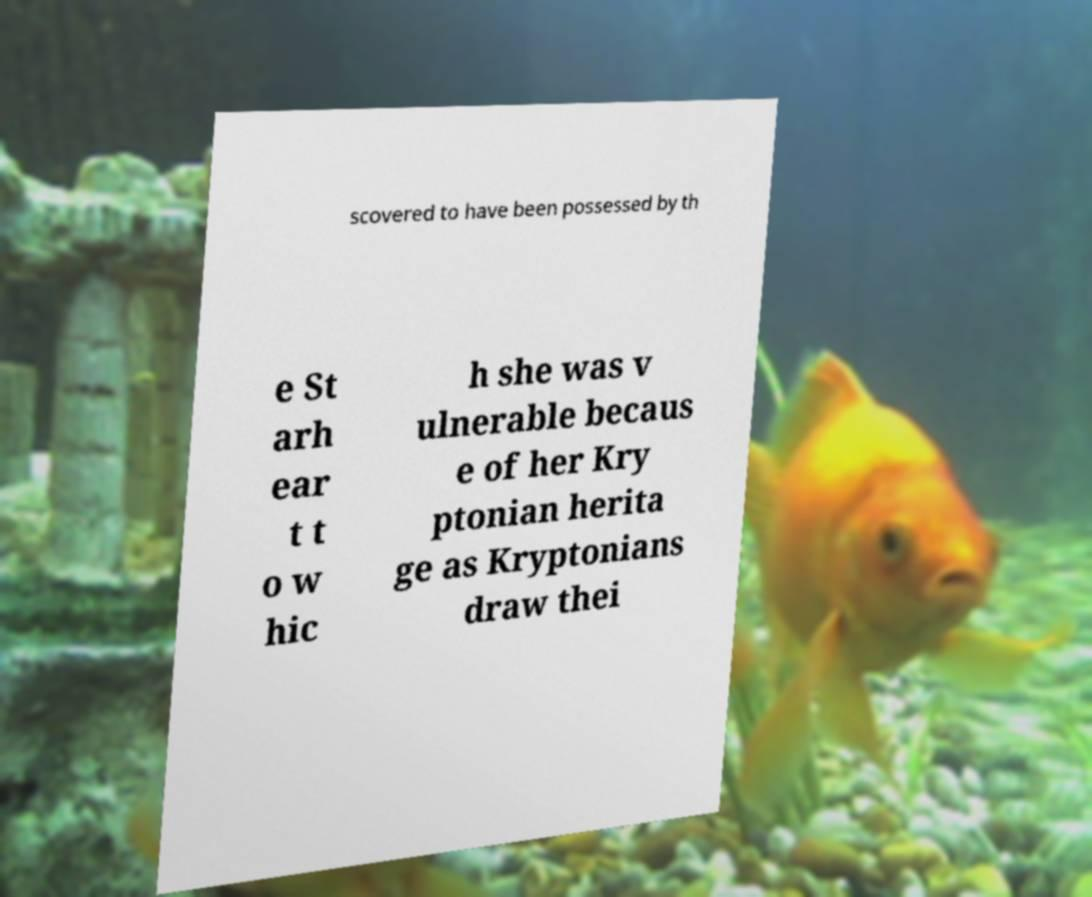Can you accurately transcribe the text from the provided image for me? scovered to have been possessed by th e St arh ear t t o w hic h she was v ulnerable becaus e of her Kry ptonian herita ge as Kryptonians draw thei 